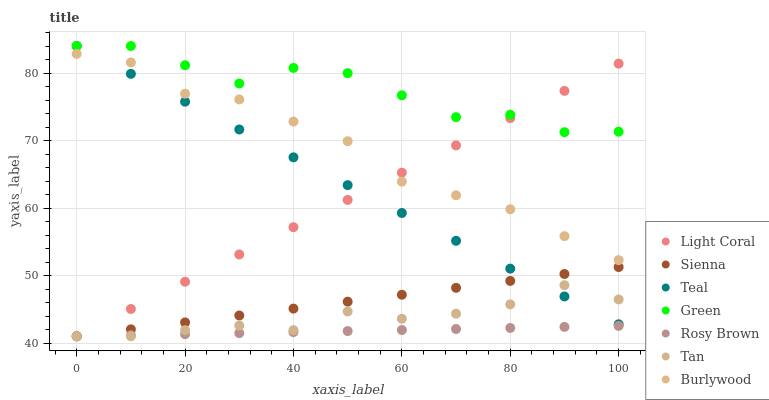Does Rosy Brown have the minimum area under the curve?
Answer yes or no. Yes. Does Green have the maximum area under the curve?
Answer yes or no. Yes. Does Burlywood have the minimum area under the curve?
Answer yes or no. No. Does Burlywood have the maximum area under the curve?
Answer yes or no. No. Is Light Coral the smoothest?
Answer yes or no. Yes. Is Green the roughest?
Answer yes or no. Yes. Is Burlywood the smoothest?
Answer yes or no. No. Is Burlywood the roughest?
Answer yes or no. No. Does Sienna have the lowest value?
Answer yes or no. Yes. Does Burlywood have the lowest value?
Answer yes or no. No. Does Teal have the highest value?
Answer yes or no. Yes. Does Burlywood have the highest value?
Answer yes or no. No. Is Tan less than Green?
Answer yes or no. Yes. Is Green greater than Rosy Brown?
Answer yes or no. Yes. Does Tan intersect Sienna?
Answer yes or no. Yes. Is Tan less than Sienna?
Answer yes or no. No. Is Tan greater than Sienna?
Answer yes or no. No. Does Tan intersect Green?
Answer yes or no. No. 